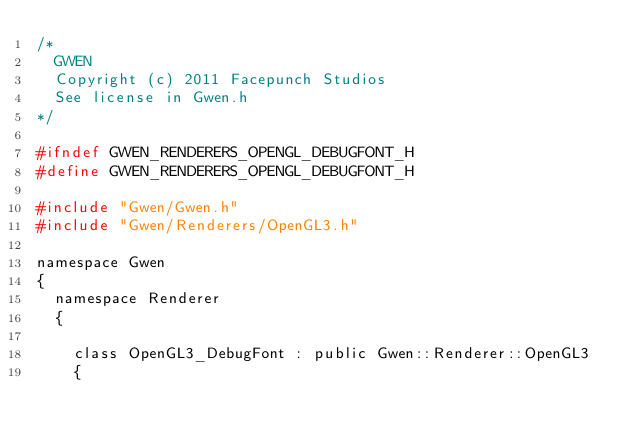Convert code to text. <code><loc_0><loc_0><loc_500><loc_500><_C_>/*
	GWEN
	Copyright (c) 2011 Facepunch Studios
	See license in Gwen.h
*/

#ifndef GWEN_RENDERERS_OPENGL_DEBUGFONT_H
#define GWEN_RENDERERS_OPENGL_DEBUGFONT_H

#include "Gwen/Gwen.h"
#include "Gwen/Renderers/OpenGL3.h"

namespace Gwen
{
	namespace Renderer
	{

		class OpenGL3_DebugFont : public Gwen::Renderer::OpenGL3
		{</code> 